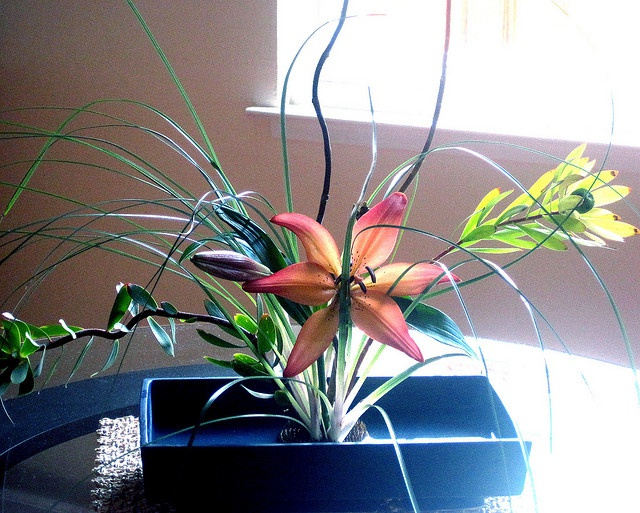Describe the objects in this image and their specific colors. I can see potted plant in gray, darkgray, and white tones and vase in gray, black, blue, navy, and lightblue tones in this image. 